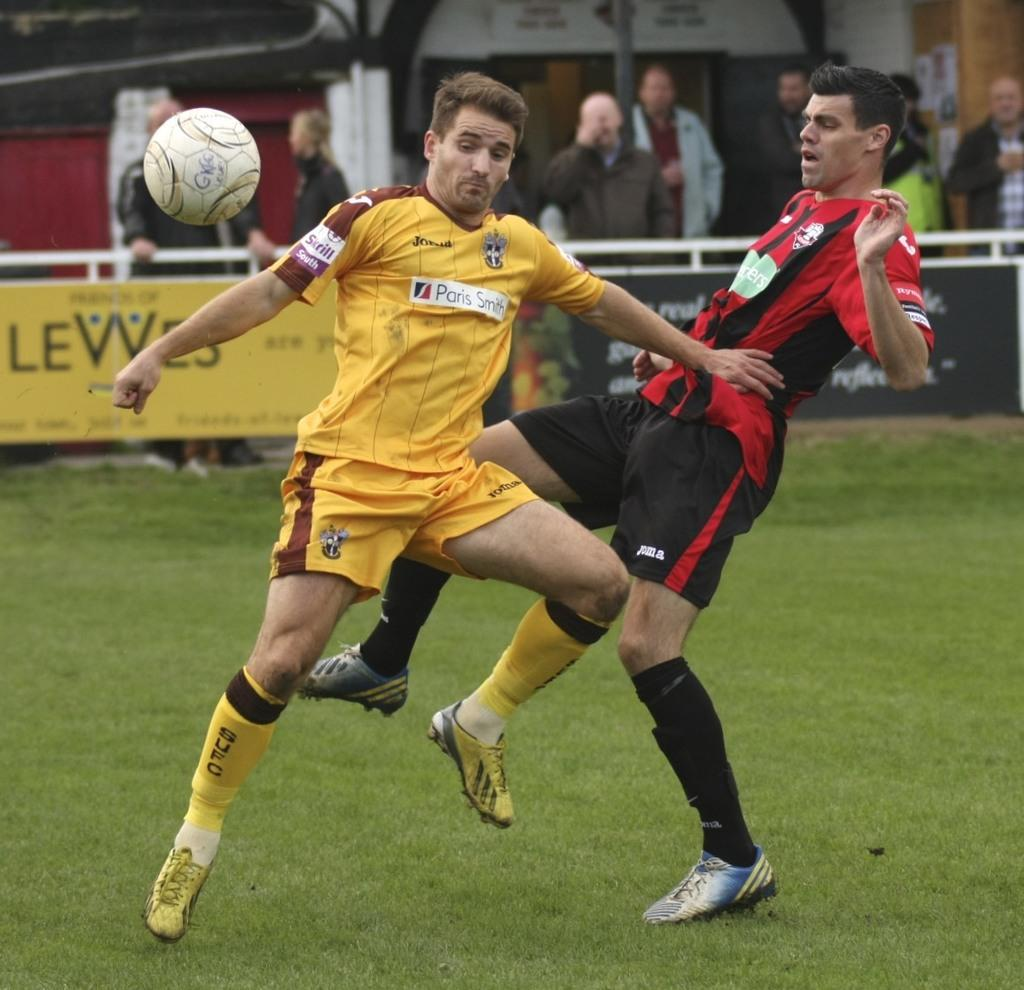How many people are in the image? There are two men in the image. What is the location of the men in the image? The men are on the grass. What is happening with the ball in the image? The ball is in the air. What can be seen in the background of the image? There are people, posters, and other objects visible in the background of the image. What type of instrument is being played by the men in the image? There is no instrument being played by the men in the image; they are simply standing on the grass with a ball in the air. 